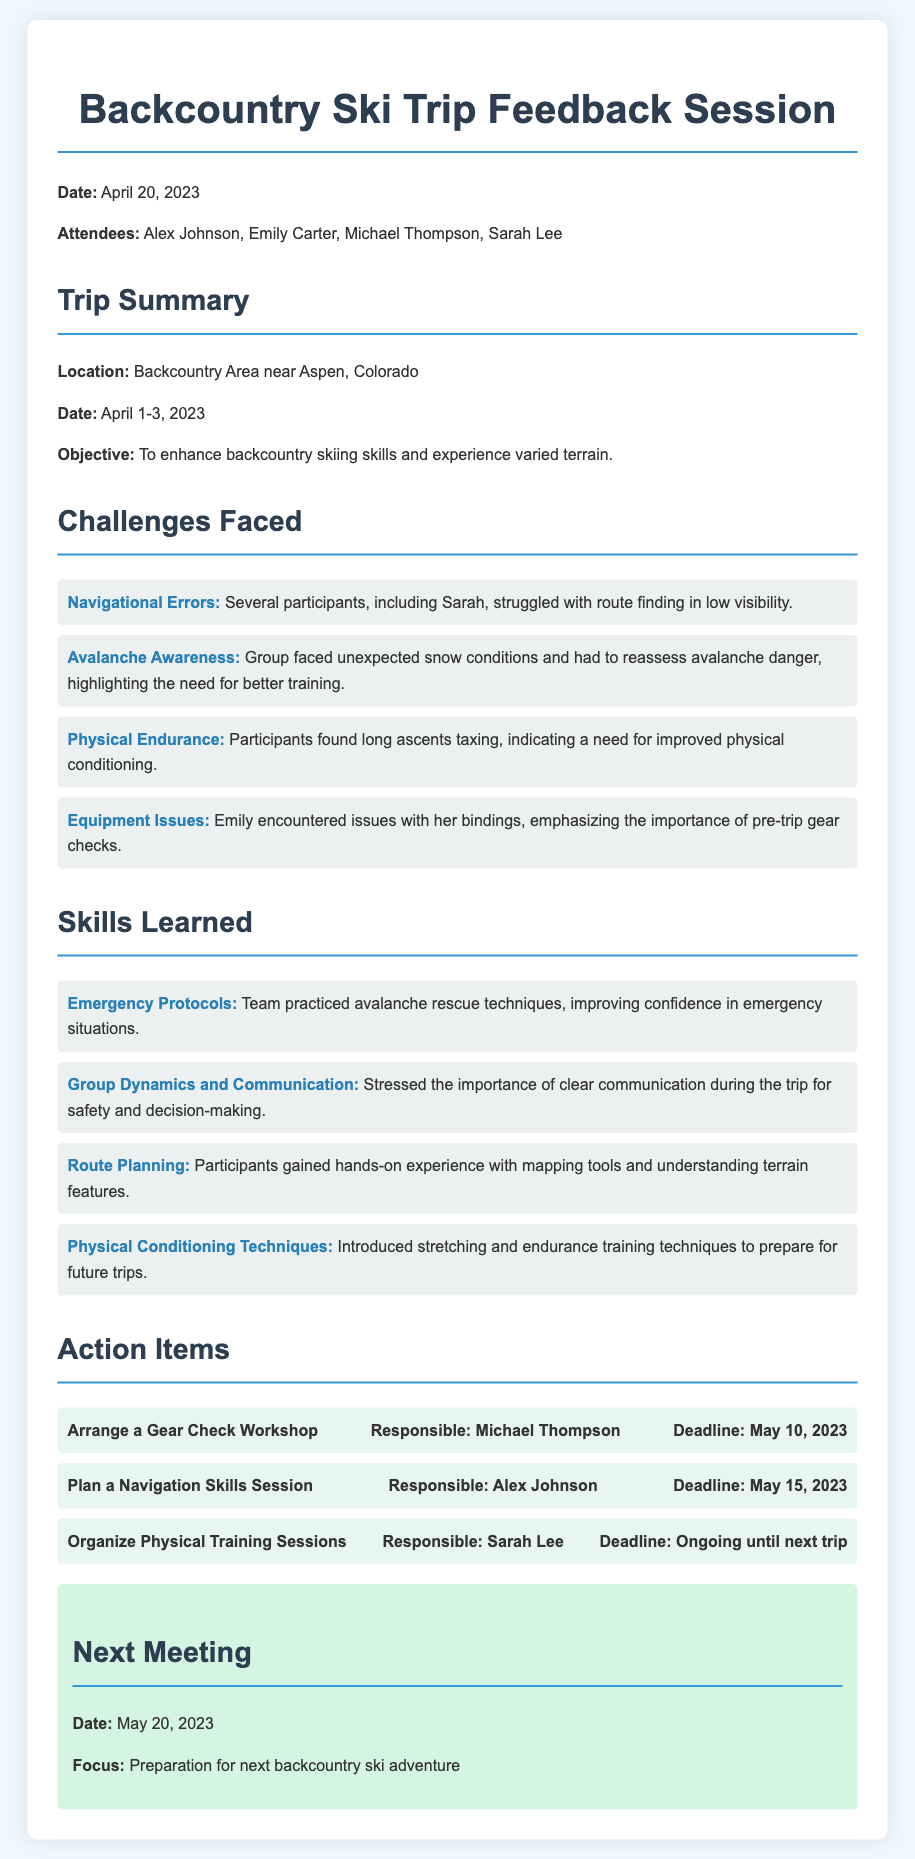what was the date of the feedback session? The date of the feedback session is specified in the document as April 20, 2023.
Answer: April 20, 2023 who was responsible for the gear check workshop? The document lists Michael Thompson as the person responsible for arranging the Gear Check Workshop.
Answer: Michael Thompson what were the dates of the backcountry ski trip? The backcountry ski trip took place from April 1 to April 3, 2023, as stated in the document.
Answer: April 1-3, 2023 which challenge involved issues with equipment? The document mentions "Equipment Issues" as a challenge faced during the trip, specifically regarding Emily's bindings.
Answer: Equipment Issues what skill related to emergency situations was practiced? The team practiced "avalanche rescue techniques," which improved their confidence in emergency situations according to the document.
Answer: avalanche rescue techniques how many attendees were present at the feedback session? The document lists four attendees at the feedback session: Alex Johnson, Emily Carter, Michael Thompson, and Sarah Lee.
Answer: Four what action item is due on May 15, 2023? The action item that is due on May 15, 2023, is "Plan a Navigation Skills Session," as indicated in the document.
Answer: Plan a Navigation Skills Session which skill emphasized the importance of communication? The document states that "Group Dynamics and Communication" was an important skill learned regarding safety and decision-making.
Answer: Group Dynamics and Communication what is the focus of the next meeting? The focus of the next meeting, scheduled for May 20, 2023, is preparation for the next backcountry ski adventure.
Answer: Preparation for next backcountry ski adventure 